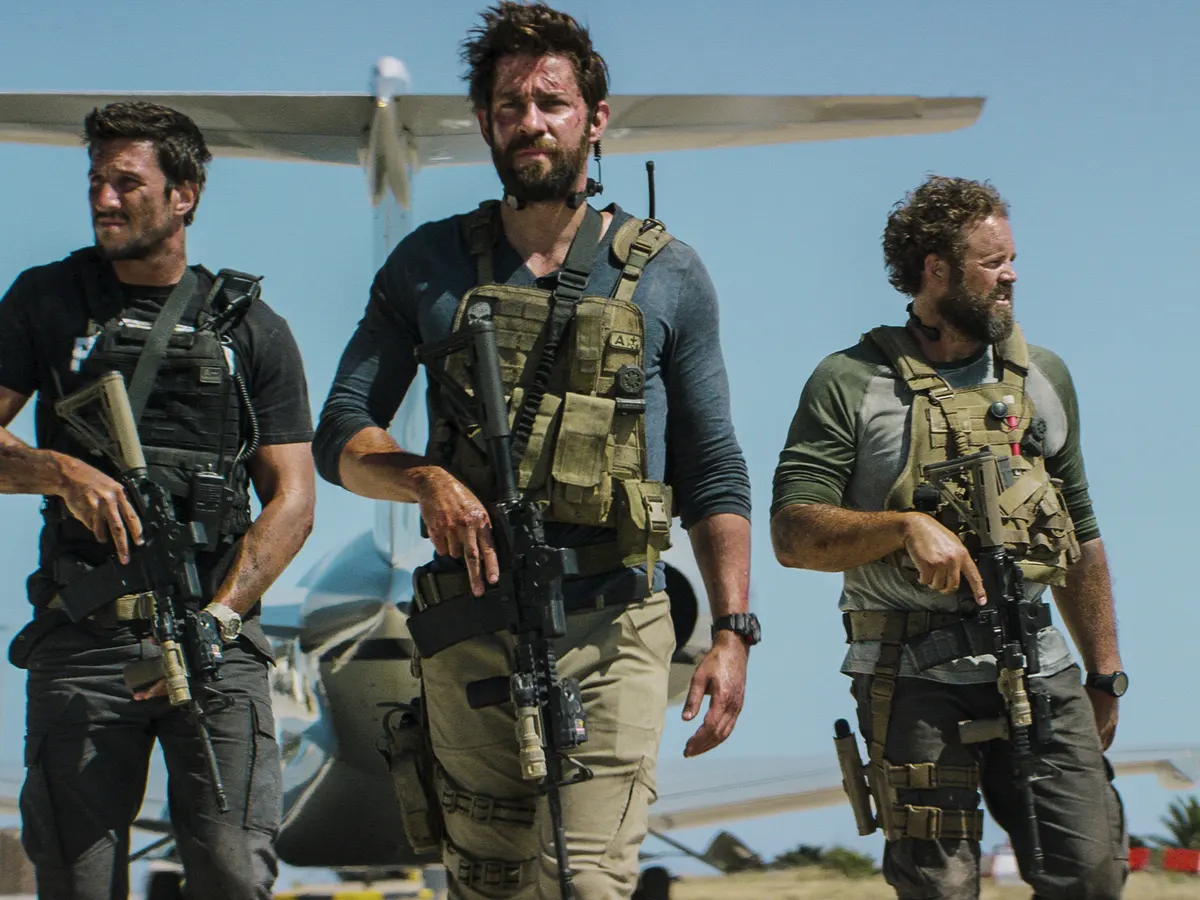Explain the visual content of the image in great detail. In the image, three men are shown walking purposefully towards the camera, exuding a sense of urgency and intensity. The central figure, appearing to be the focus, has a rugged and determined look, dressed in a beige tactical vest over a dark long-sleeve shirt. He carries a rifle, indicative of a prepared and armed stance. His companions on either side are also equipped similarly, clad in tactical gear with rifles at the ready. The setting appears to be a desert-like area, suggested by the sandy ground underfoot. Behind them, a small aircraft rests on a runway, bathed in sunlight with a clear blue sky above. Their coordinated movement and serious expressions suggest they are engaged in a mission or operation, ready for action in what appears to be a tense and demanding environment. 